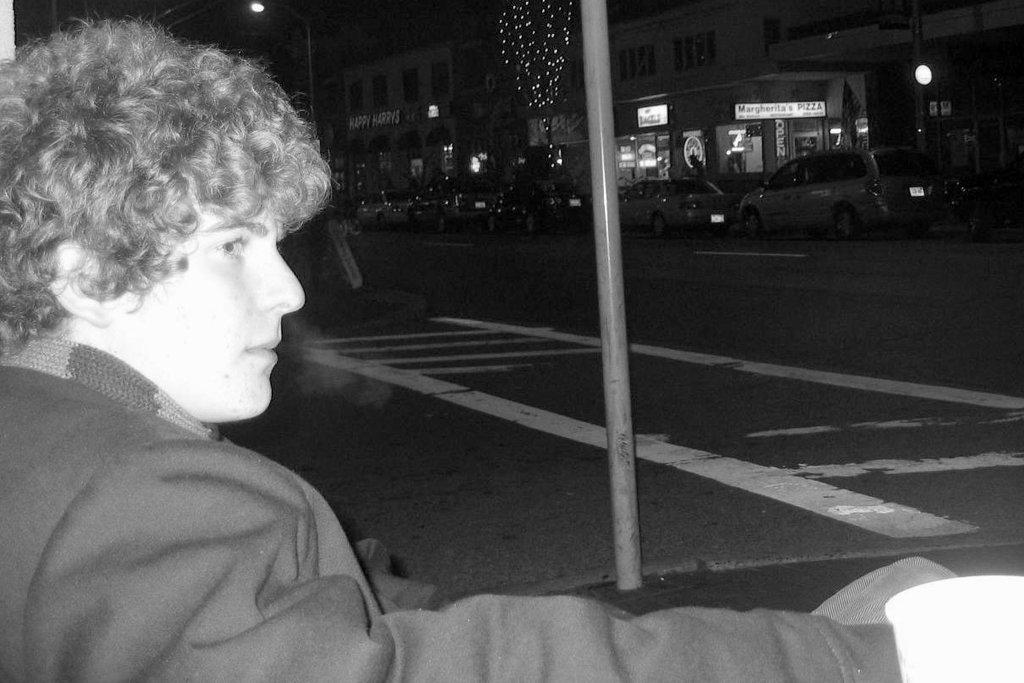What is located on the left side of the image? There is a person on the left side of the image. What can be seen in the background of the image? There are poles, buildings, trees, vehicles, lights, and some objects in the background of the image. What is at the bottom of the image? There is a road at the bottom of the image. What type of island can be seen in the image? There is no island present in the image. What is the aftermath of the event in the image? There is no event or aftermath depicted in the image. 